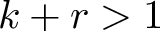<formula> <loc_0><loc_0><loc_500><loc_500>k + r > 1</formula> 